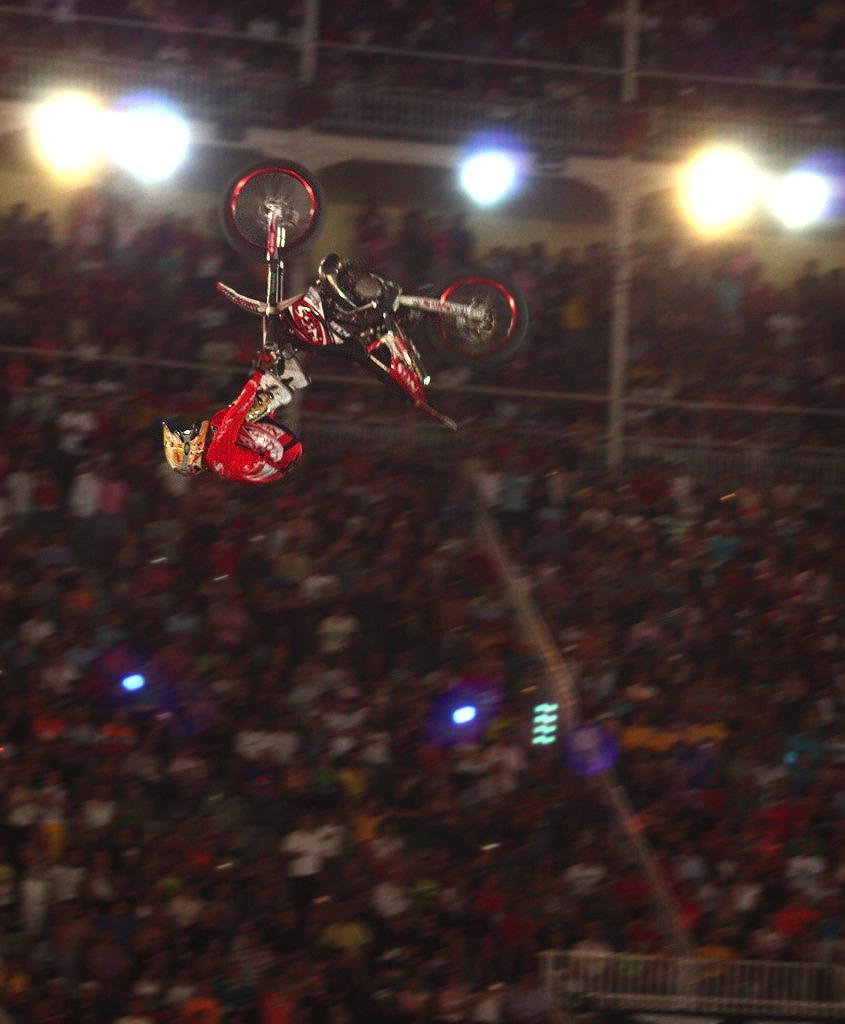How would you summarize this image in a sentence or two? At the top of this image, there is a person in a red color dress, holding the handle of a bike in the air. Under this person, there are persons. In the background, there are lights arranged, there are persons and fences. 